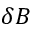Convert formula to latex. <formula><loc_0><loc_0><loc_500><loc_500>\delta B</formula> 